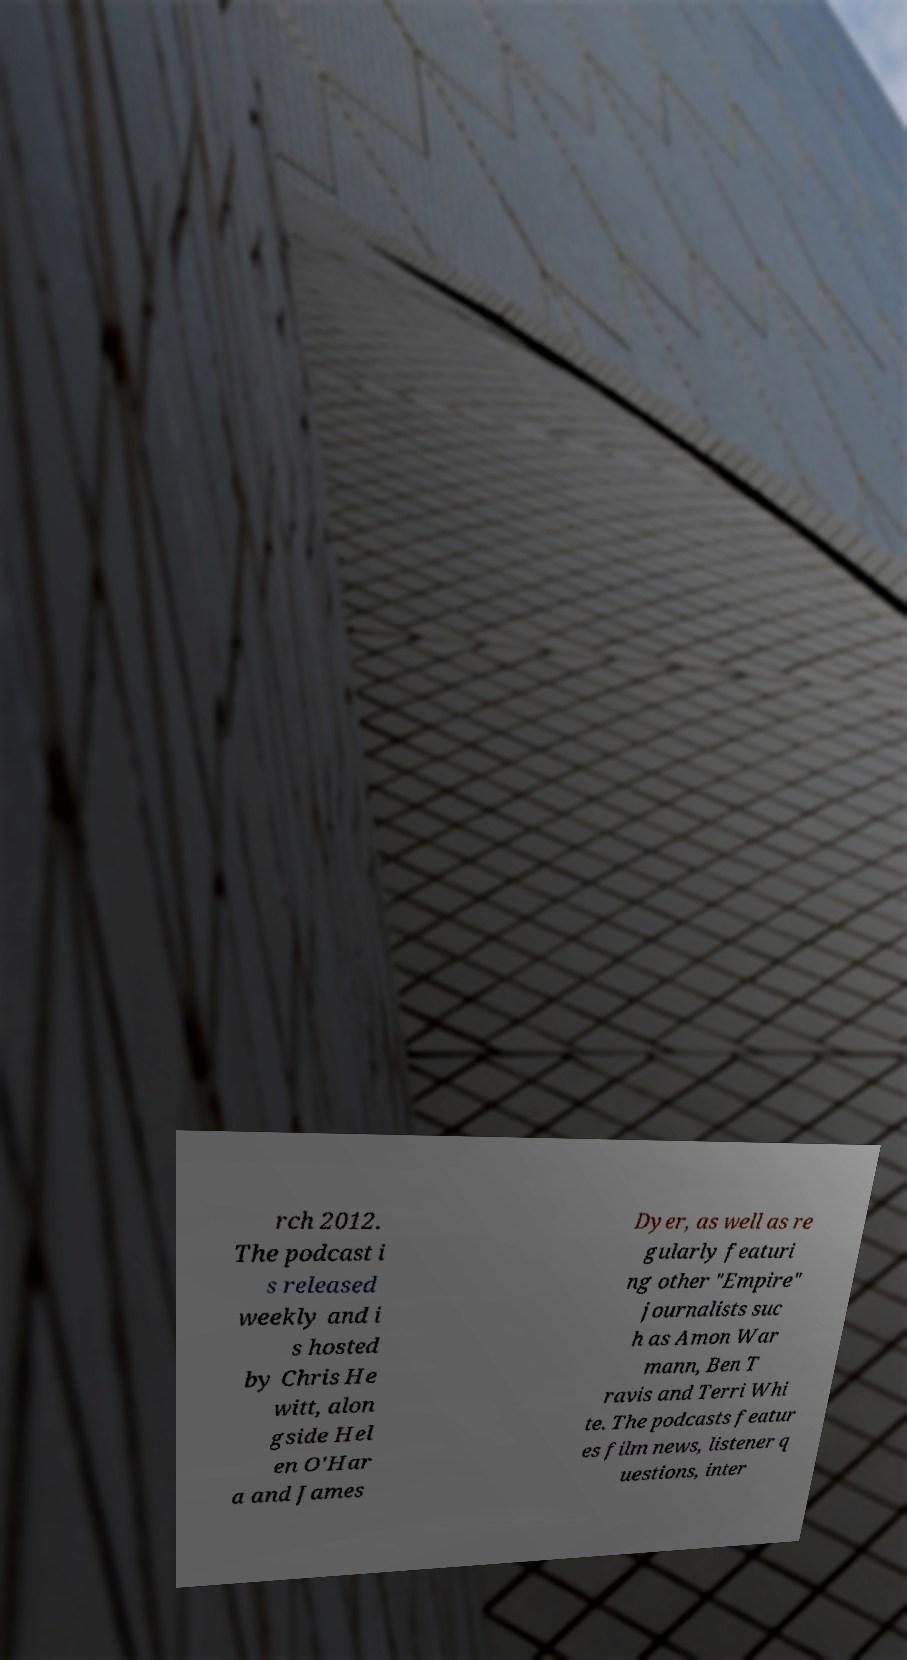Could you assist in decoding the text presented in this image and type it out clearly? rch 2012. The podcast i s released weekly and i s hosted by Chris He witt, alon gside Hel en O'Har a and James Dyer, as well as re gularly featuri ng other "Empire" journalists suc h as Amon War mann, Ben T ravis and Terri Whi te. The podcasts featur es film news, listener q uestions, inter 